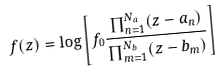<formula> <loc_0><loc_0><loc_500><loc_500>f ( z ) = \log \left [ f _ { 0 } \frac { \prod _ { n = 1 } ^ { N _ { a } } ( z - a _ { n } ) } { \prod _ { m = 1 } ^ { N _ { b } } ( z - b _ { m } ) } \right ]</formula> 